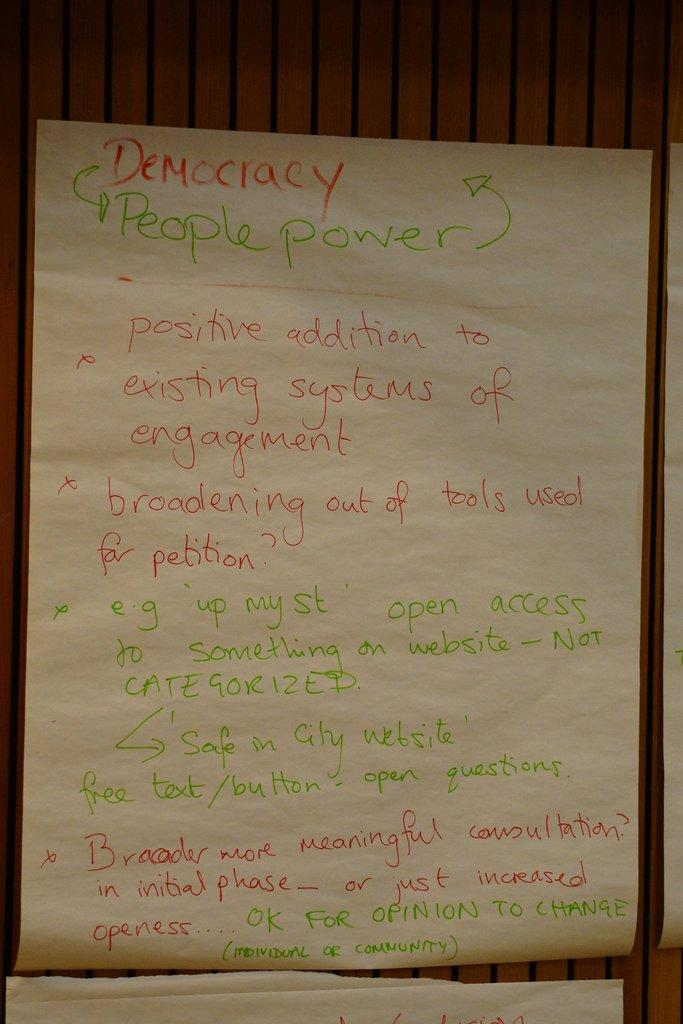<image>
Give a short and clear explanation of the subsequent image. A sheet of paper with democracy at the top 